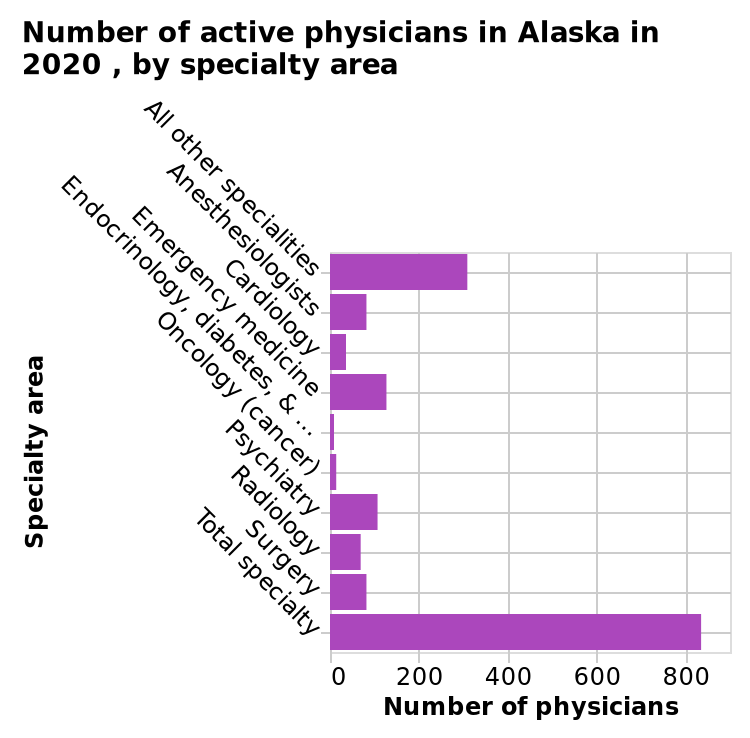<image>
What are the two highest specialist fields?  The two highest specialist fields are cardiologist and psychologist. Which specialist field has the least number in terms of ontology? Ontology has the least number among specialist fields. 